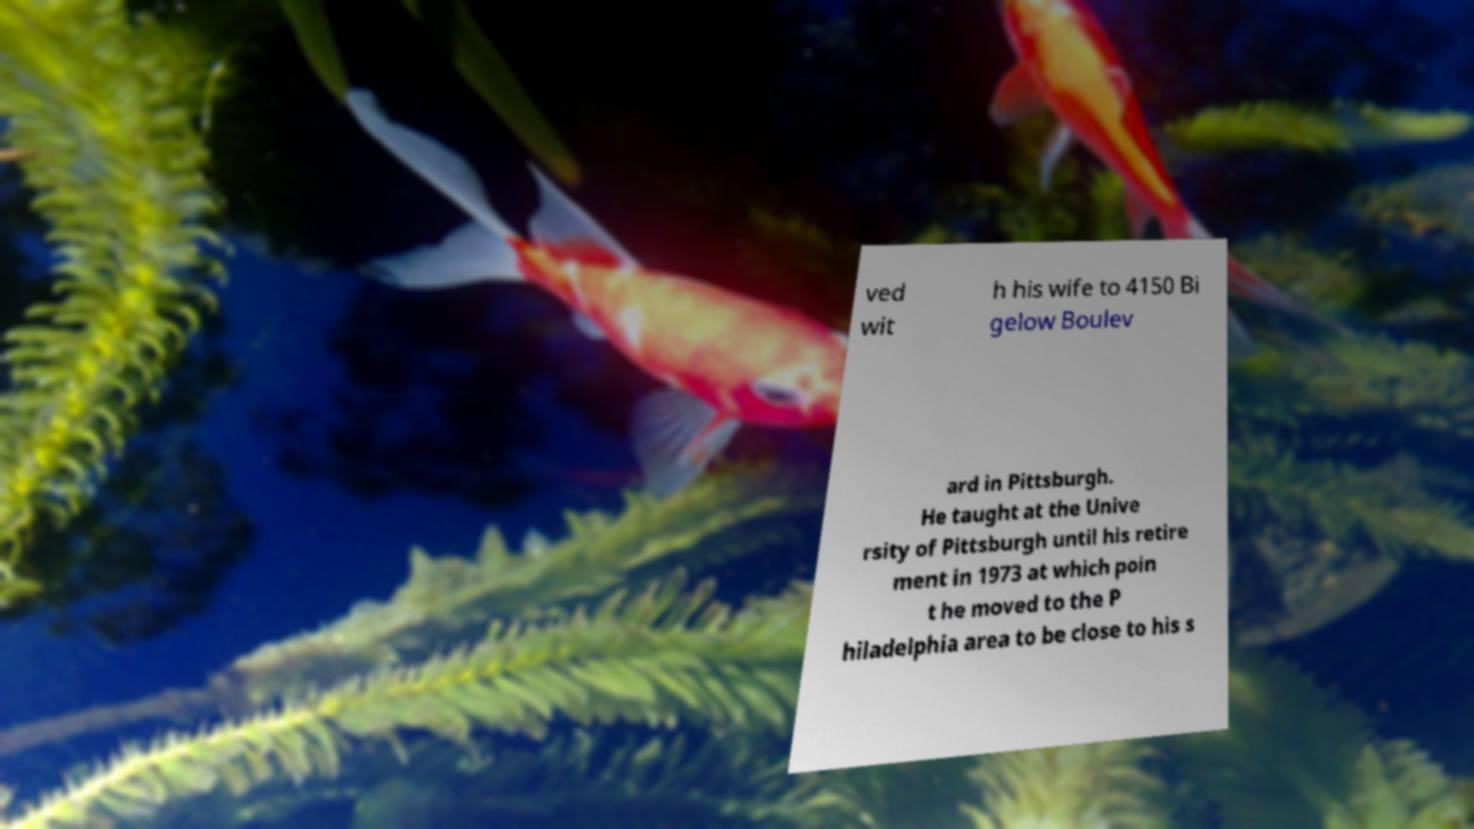Can you read and provide the text displayed in the image?This photo seems to have some interesting text. Can you extract and type it out for me? ved wit h his wife to 4150 Bi gelow Boulev ard in Pittsburgh. He taught at the Unive rsity of Pittsburgh until his retire ment in 1973 at which poin t he moved to the P hiladelphia area to be close to his s 